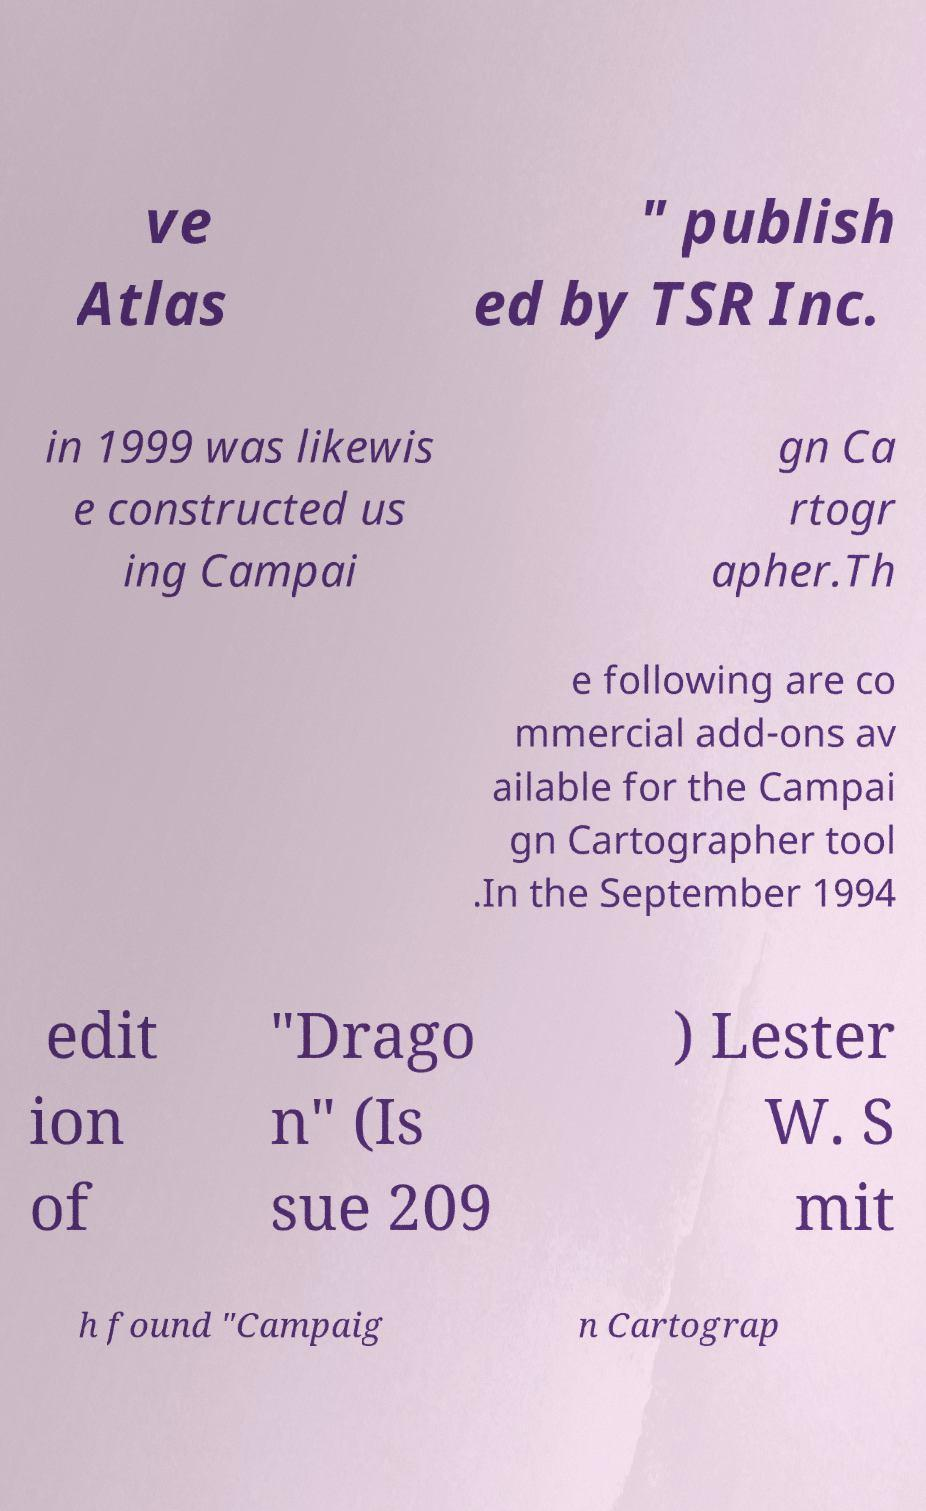Can you accurately transcribe the text from the provided image for me? ve Atlas " publish ed by TSR Inc. in 1999 was likewis e constructed us ing Campai gn Ca rtogr apher.Th e following are co mmercial add-ons av ailable for the Campai gn Cartographer tool .In the September 1994 edit ion of "Drago n" (Is sue 209 ) Lester W. S mit h found "Campaig n Cartograp 